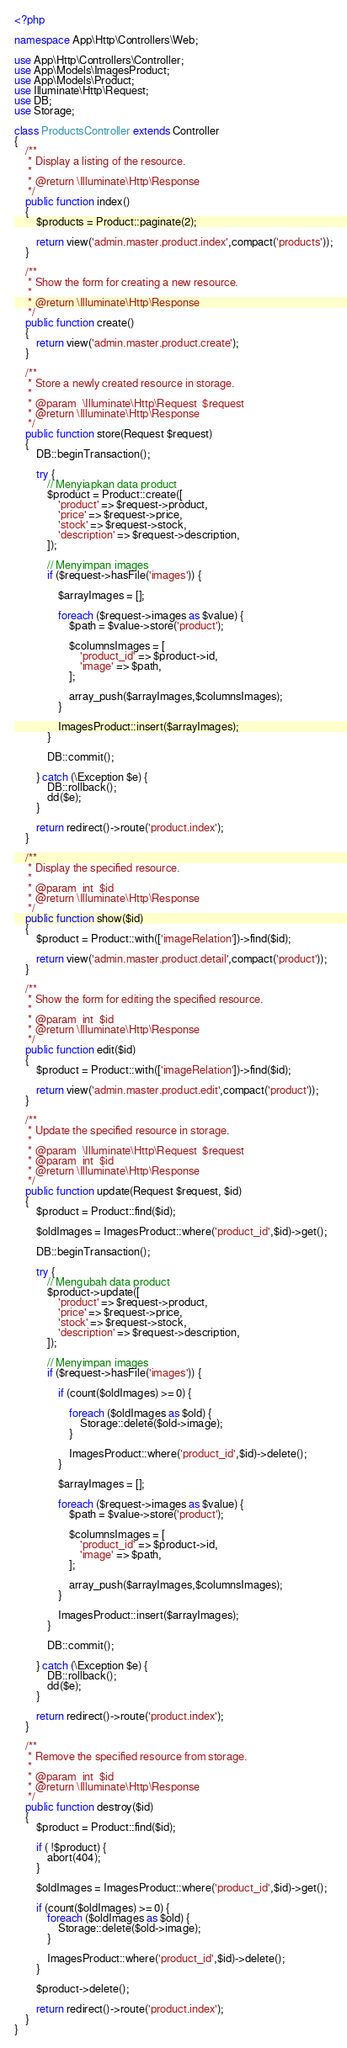<code> <loc_0><loc_0><loc_500><loc_500><_PHP_><?php

namespace App\Http\Controllers\Web;

use App\Http\Controllers\Controller;
use App\Models\ImagesProduct;
use App\Models\Product;
use Illuminate\Http\Request;
use DB;
use Storage;

class ProductsController extends Controller
{
    /**
     * Display a listing of the resource.
     *
     * @return \Illuminate\Http\Response
     */
    public function index()
    {
        $products = Product::paginate(2);

        return view('admin.master.product.index',compact('products'));
    }

    /**
     * Show the form for creating a new resource.
     *
     * @return \Illuminate\Http\Response
     */
    public function create()
    {
        return view('admin.master.product.create');
    }

    /**
     * Store a newly created resource in storage.
     *
     * @param  \Illuminate\Http\Request  $request
     * @return \Illuminate\Http\Response
     */
    public function store(Request $request)
    {
        DB::beginTransaction();

        try {
            // Menyiapkan data product
            $product = Product::create([
                'product' => $request->product,
                'price' => $request->price,
                'stock' => $request->stock,
                'description' => $request->description,
            ]);

            // Menyimpan images
            if ($request->hasFile('images')) {

                $arrayImages = [];

                foreach ($request->images as $value) {
                    $path = $value->store('product');

                    $columnsImages = [
                        'product_id' => $product->id,
                        'image' => $path,
                    ];

                    array_push($arrayImages,$columnsImages);
                }

                ImagesProduct::insert($arrayImages);
            }

            DB::commit();

        } catch (\Exception $e) {
            DB::rollback();
            dd($e);
        }

        return redirect()->route('product.index');
    }

    /**
     * Display the specified resource.
     *
     * @param  int  $id
     * @return \Illuminate\Http\Response
     */
    public function show($id)
    {
        $product = Product::with(['imageRelation'])->find($id);

        return view('admin.master.product.detail',compact('product'));
    }

    /**
     * Show the form for editing the specified resource.
     *
     * @param  int  $id
     * @return \Illuminate\Http\Response
     */
    public function edit($id)
    {
        $product = Product::with(['imageRelation'])->find($id);

        return view('admin.master.product.edit',compact('product'));
    }

    /**
     * Update the specified resource in storage.
     *
     * @param  \Illuminate\Http\Request  $request
     * @param  int  $id
     * @return \Illuminate\Http\Response
     */
    public function update(Request $request, $id)
    {
        $product = Product::find($id);

        $oldImages = ImagesProduct::where('product_id',$id)->get();

        DB::beginTransaction();

        try {
            // Mengubah data product
            $product->update([
                'product' => $request->product,
                'price' => $request->price,
                'stock' => $request->stock,
                'description' => $request->description,
            ]);

            // Menyimpan images
            if ($request->hasFile('images')) {

                if (count($oldImages) >= 0) {

                    foreach ($oldImages as $old) {
                        Storage::delete($old->image);
                    }

                    ImagesProduct::where('product_id',$id)->delete();
                }

                $arrayImages = [];

                foreach ($request->images as $value) {
                    $path = $value->store('product');

                    $columnsImages = [
                        'product_id' => $product->id,
                        'image' => $path,
                    ];

                    array_push($arrayImages,$columnsImages);
                }

                ImagesProduct::insert($arrayImages);
            }

            DB::commit();

        } catch (\Exception $e) {
            DB::rollback();
            dd($e);
        }

        return redirect()->route('product.index');
    }

    /**
     * Remove the specified resource from storage.
     *
     * @param  int  $id
     * @return \Illuminate\Http\Response
     */
    public function destroy($id)
    {
        $product = Product::find($id);

        if ( !$product) {
            abort(404);
        }

        $oldImages = ImagesProduct::where('product_id',$id)->get();

        if (count($oldImages) >= 0) {
            foreach ($oldImages as $old) {
                Storage::delete($old->image);
            }

            ImagesProduct::where('product_id',$id)->delete();
        }

        $product->delete();

        return redirect()->route('product.index');
    }
}
</code> 